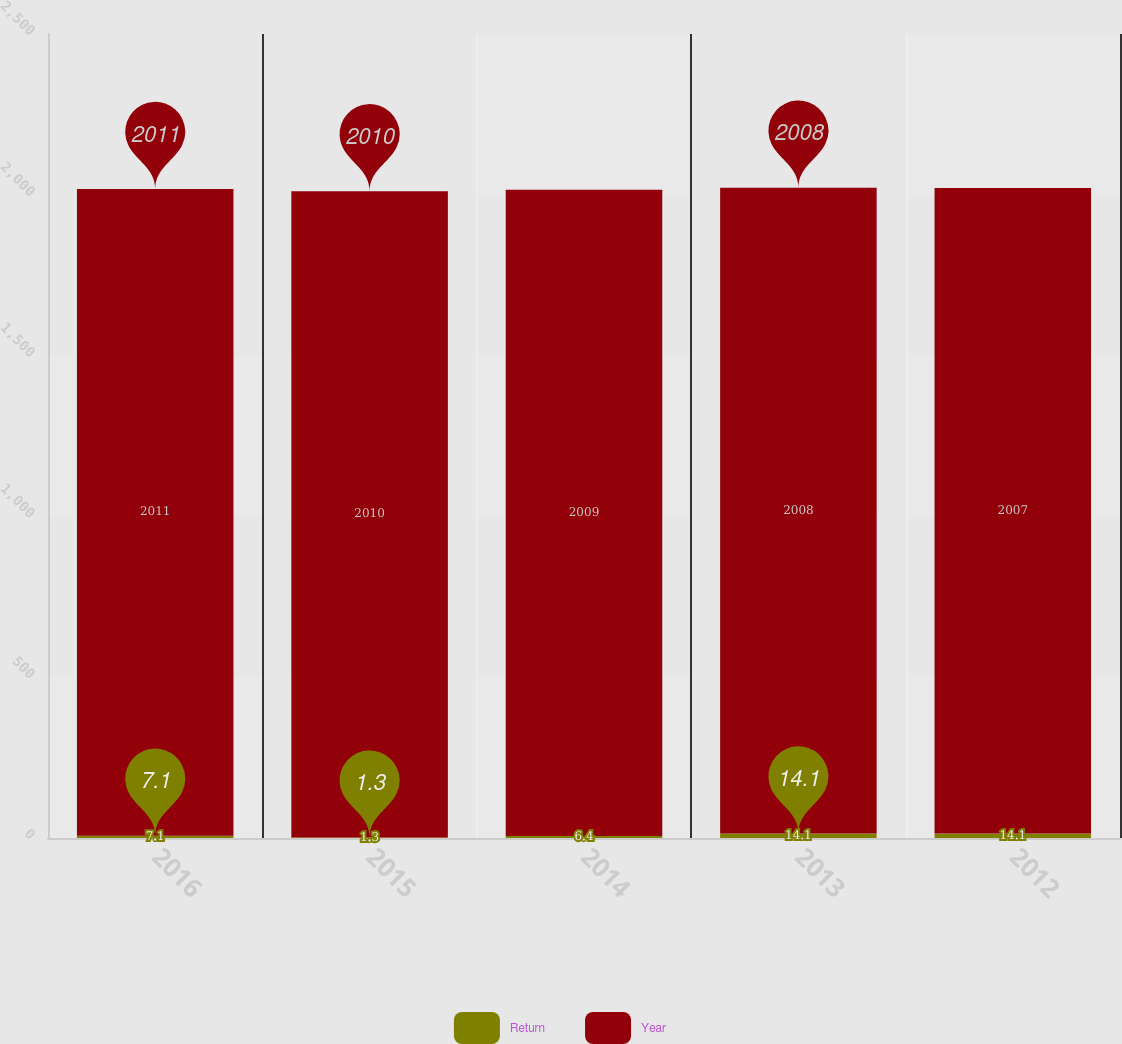Convert chart to OTSL. <chart><loc_0><loc_0><loc_500><loc_500><stacked_bar_chart><ecel><fcel>2016<fcel>2015<fcel>2014<fcel>2013<fcel>2012<nl><fcel>Return<fcel>7.1<fcel>1.3<fcel>6.4<fcel>14.1<fcel>14.1<nl><fcel>Year<fcel>2011<fcel>2010<fcel>2009<fcel>2008<fcel>2007<nl></chart> 